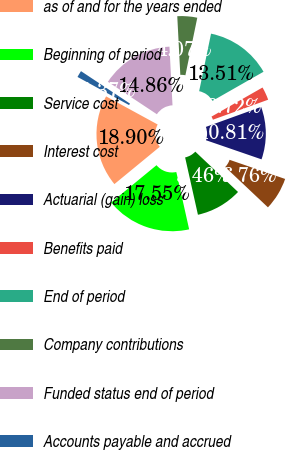Convert chart to OTSL. <chart><loc_0><loc_0><loc_500><loc_500><pie_chart><fcel>as of and for the years ended<fcel>Beginning of period<fcel>Service cost<fcel>Interest cost<fcel>Actuarial (gain) loss<fcel>Benefits paid<fcel>End of period<fcel>Company contributions<fcel>Funded status end of period<fcel>Accounts payable and accrued<nl><fcel>18.9%<fcel>17.55%<fcel>9.46%<fcel>6.76%<fcel>10.81%<fcel>2.72%<fcel>13.51%<fcel>4.07%<fcel>14.86%<fcel>1.37%<nl></chart> 